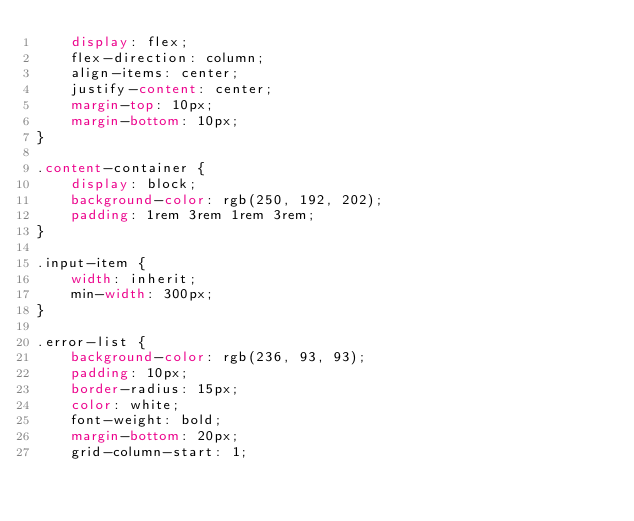Convert code to text. <code><loc_0><loc_0><loc_500><loc_500><_CSS_>    display: flex;
    flex-direction: column;
    align-items: center;
    justify-content: center;
    margin-top: 10px;
    margin-bottom: 10px;
}

.content-container {
    display: block;
    background-color: rgb(250, 192, 202);
    padding: 1rem 3rem 1rem 3rem;
}

.input-item {
    width: inherit;
    min-width: 300px;
}

.error-list {
    background-color: rgb(236, 93, 93);
    padding: 10px;
    border-radius: 15px;
    color: white;
    font-weight: bold;
    margin-bottom: 20px;
    grid-column-start: 1;</code> 